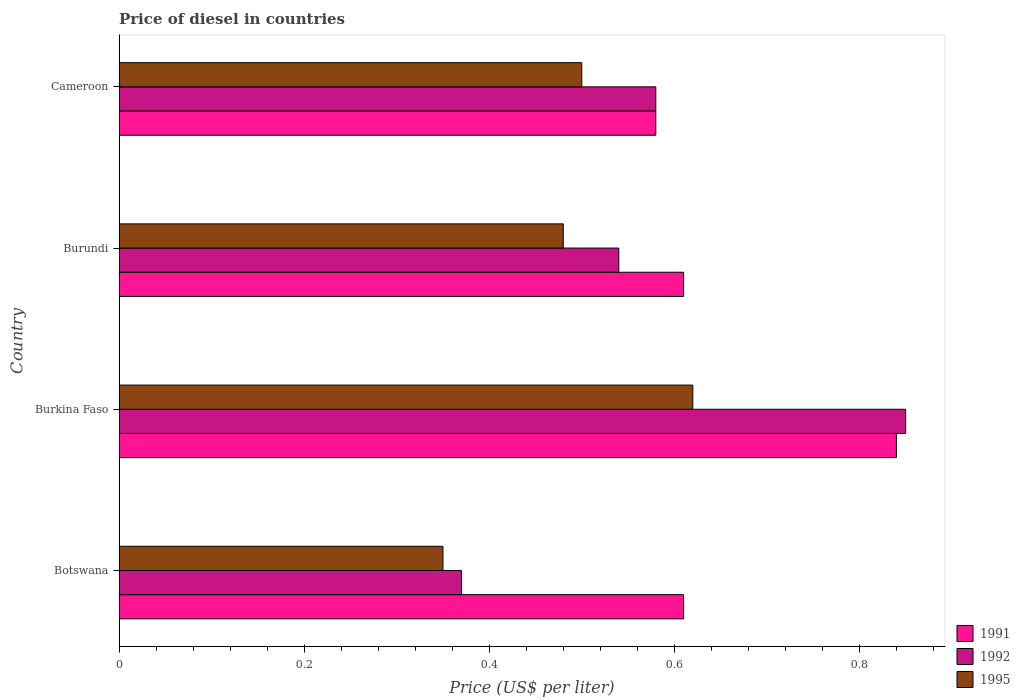How many different coloured bars are there?
Your answer should be very brief. 3. How many groups of bars are there?
Provide a short and direct response. 4. Are the number of bars per tick equal to the number of legend labels?
Your answer should be compact. Yes. How many bars are there on the 1st tick from the top?
Provide a succinct answer. 3. How many bars are there on the 1st tick from the bottom?
Provide a succinct answer. 3. What is the label of the 2nd group of bars from the top?
Your answer should be compact. Burundi. What is the price of diesel in 1991 in Botswana?
Your answer should be very brief. 0.61. Across all countries, what is the maximum price of diesel in 1991?
Provide a short and direct response. 0.84. In which country was the price of diesel in 1995 maximum?
Keep it short and to the point. Burkina Faso. In which country was the price of diesel in 1995 minimum?
Your response must be concise. Botswana. What is the total price of diesel in 1995 in the graph?
Your answer should be very brief. 1.95. What is the difference between the price of diesel in 1992 in Botswana and that in Burkina Faso?
Make the answer very short. -0.48. What is the difference between the price of diesel in 1992 in Cameroon and the price of diesel in 1991 in Botswana?
Your response must be concise. -0.03. What is the average price of diesel in 1992 per country?
Make the answer very short. 0.58. What is the difference between the price of diesel in 1992 and price of diesel in 1995 in Burkina Faso?
Your answer should be compact. 0.23. What is the ratio of the price of diesel in 1991 in Burkina Faso to that in Cameroon?
Your answer should be very brief. 1.45. Is the price of diesel in 1995 in Botswana less than that in Burundi?
Your response must be concise. Yes. What is the difference between the highest and the second highest price of diesel in 1991?
Your answer should be compact. 0.23. What is the difference between the highest and the lowest price of diesel in 1992?
Provide a succinct answer. 0.48. In how many countries, is the price of diesel in 1992 greater than the average price of diesel in 1992 taken over all countries?
Your answer should be very brief. 1. Is it the case that in every country, the sum of the price of diesel in 1992 and price of diesel in 1995 is greater than the price of diesel in 1991?
Provide a succinct answer. Yes. How many countries are there in the graph?
Your answer should be very brief. 4. What is the difference between two consecutive major ticks on the X-axis?
Ensure brevity in your answer.  0.2. Does the graph contain any zero values?
Ensure brevity in your answer.  No. How many legend labels are there?
Your answer should be compact. 3. What is the title of the graph?
Ensure brevity in your answer.  Price of diesel in countries. Does "2014" appear as one of the legend labels in the graph?
Give a very brief answer. No. What is the label or title of the X-axis?
Offer a very short reply. Price (US$ per liter). What is the Price (US$ per liter) in 1991 in Botswana?
Offer a very short reply. 0.61. What is the Price (US$ per liter) in 1992 in Botswana?
Offer a very short reply. 0.37. What is the Price (US$ per liter) in 1995 in Botswana?
Your answer should be very brief. 0.35. What is the Price (US$ per liter) in 1991 in Burkina Faso?
Your answer should be very brief. 0.84. What is the Price (US$ per liter) in 1992 in Burkina Faso?
Offer a terse response. 0.85. What is the Price (US$ per liter) in 1995 in Burkina Faso?
Offer a terse response. 0.62. What is the Price (US$ per liter) in 1991 in Burundi?
Your response must be concise. 0.61. What is the Price (US$ per liter) of 1992 in Burundi?
Keep it short and to the point. 0.54. What is the Price (US$ per liter) in 1995 in Burundi?
Make the answer very short. 0.48. What is the Price (US$ per liter) in 1991 in Cameroon?
Provide a succinct answer. 0.58. What is the Price (US$ per liter) of 1992 in Cameroon?
Offer a very short reply. 0.58. What is the Price (US$ per liter) in 1995 in Cameroon?
Make the answer very short. 0.5. Across all countries, what is the maximum Price (US$ per liter) in 1991?
Give a very brief answer. 0.84. Across all countries, what is the maximum Price (US$ per liter) in 1992?
Your response must be concise. 0.85. Across all countries, what is the maximum Price (US$ per liter) of 1995?
Offer a terse response. 0.62. Across all countries, what is the minimum Price (US$ per liter) in 1991?
Provide a short and direct response. 0.58. Across all countries, what is the minimum Price (US$ per liter) in 1992?
Ensure brevity in your answer.  0.37. Across all countries, what is the minimum Price (US$ per liter) of 1995?
Your response must be concise. 0.35. What is the total Price (US$ per liter) in 1991 in the graph?
Keep it short and to the point. 2.64. What is the total Price (US$ per liter) of 1992 in the graph?
Keep it short and to the point. 2.34. What is the total Price (US$ per liter) in 1995 in the graph?
Provide a short and direct response. 1.95. What is the difference between the Price (US$ per liter) in 1991 in Botswana and that in Burkina Faso?
Your answer should be compact. -0.23. What is the difference between the Price (US$ per liter) in 1992 in Botswana and that in Burkina Faso?
Ensure brevity in your answer.  -0.48. What is the difference between the Price (US$ per liter) of 1995 in Botswana and that in Burkina Faso?
Your answer should be very brief. -0.27. What is the difference between the Price (US$ per liter) in 1992 in Botswana and that in Burundi?
Offer a terse response. -0.17. What is the difference between the Price (US$ per liter) of 1995 in Botswana and that in Burundi?
Keep it short and to the point. -0.13. What is the difference between the Price (US$ per liter) in 1991 in Botswana and that in Cameroon?
Your response must be concise. 0.03. What is the difference between the Price (US$ per liter) in 1992 in Botswana and that in Cameroon?
Your answer should be compact. -0.21. What is the difference between the Price (US$ per liter) in 1991 in Burkina Faso and that in Burundi?
Your response must be concise. 0.23. What is the difference between the Price (US$ per liter) of 1992 in Burkina Faso and that in Burundi?
Your answer should be compact. 0.31. What is the difference between the Price (US$ per liter) of 1995 in Burkina Faso and that in Burundi?
Make the answer very short. 0.14. What is the difference between the Price (US$ per liter) in 1991 in Burkina Faso and that in Cameroon?
Your answer should be very brief. 0.26. What is the difference between the Price (US$ per liter) in 1992 in Burkina Faso and that in Cameroon?
Provide a succinct answer. 0.27. What is the difference between the Price (US$ per liter) of 1995 in Burkina Faso and that in Cameroon?
Offer a terse response. 0.12. What is the difference between the Price (US$ per liter) in 1991 in Burundi and that in Cameroon?
Offer a very short reply. 0.03. What is the difference between the Price (US$ per liter) in 1992 in Burundi and that in Cameroon?
Provide a succinct answer. -0.04. What is the difference between the Price (US$ per liter) in 1995 in Burundi and that in Cameroon?
Provide a succinct answer. -0.02. What is the difference between the Price (US$ per liter) in 1991 in Botswana and the Price (US$ per liter) in 1992 in Burkina Faso?
Make the answer very short. -0.24. What is the difference between the Price (US$ per liter) in 1991 in Botswana and the Price (US$ per liter) in 1995 in Burkina Faso?
Ensure brevity in your answer.  -0.01. What is the difference between the Price (US$ per liter) of 1991 in Botswana and the Price (US$ per liter) of 1992 in Burundi?
Keep it short and to the point. 0.07. What is the difference between the Price (US$ per liter) of 1991 in Botswana and the Price (US$ per liter) of 1995 in Burundi?
Offer a very short reply. 0.13. What is the difference between the Price (US$ per liter) of 1992 in Botswana and the Price (US$ per liter) of 1995 in Burundi?
Your answer should be compact. -0.11. What is the difference between the Price (US$ per liter) of 1991 in Botswana and the Price (US$ per liter) of 1995 in Cameroon?
Your answer should be compact. 0.11. What is the difference between the Price (US$ per liter) of 1992 in Botswana and the Price (US$ per liter) of 1995 in Cameroon?
Ensure brevity in your answer.  -0.13. What is the difference between the Price (US$ per liter) of 1991 in Burkina Faso and the Price (US$ per liter) of 1995 in Burundi?
Offer a very short reply. 0.36. What is the difference between the Price (US$ per liter) in 1992 in Burkina Faso and the Price (US$ per liter) in 1995 in Burundi?
Ensure brevity in your answer.  0.37. What is the difference between the Price (US$ per liter) in 1991 in Burkina Faso and the Price (US$ per liter) in 1992 in Cameroon?
Provide a short and direct response. 0.26. What is the difference between the Price (US$ per liter) in 1991 in Burkina Faso and the Price (US$ per liter) in 1995 in Cameroon?
Offer a very short reply. 0.34. What is the difference between the Price (US$ per liter) of 1992 in Burkina Faso and the Price (US$ per liter) of 1995 in Cameroon?
Your answer should be very brief. 0.35. What is the difference between the Price (US$ per liter) of 1991 in Burundi and the Price (US$ per liter) of 1995 in Cameroon?
Provide a short and direct response. 0.11. What is the average Price (US$ per liter) in 1991 per country?
Provide a short and direct response. 0.66. What is the average Price (US$ per liter) of 1992 per country?
Ensure brevity in your answer.  0.58. What is the average Price (US$ per liter) in 1995 per country?
Your answer should be compact. 0.49. What is the difference between the Price (US$ per liter) of 1991 and Price (US$ per liter) of 1992 in Botswana?
Offer a very short reply. 0.24. What is the difference between the Price (US$ per liter) in 1991 and Price (US$ per liter) in 1995 in Botswana?
Offer a terse response. 0.26. What is the difference between the Price (US$ per liter) in 1991 and Price (US$ per liter) in 1992 in Burkina Faso?
Your answer should be very brief. -0.01. What is the difference between the Price (US$ per liter) in 1991 and Price (US$ per liter) in 1995 in Burkina Faso?
Provide a succinct answer. 0.22. What is the difference between the Price (US$ per liter) of 1992 and Price (US$ per liter) of 1995 in Burkina Faso?
Provide a short and direct response. 0.23. What is the difference between the Price (US$ per liter) in 1991 and Price (US$ per liter) in 1992 in Burundi?
Make the answer very short. 0.07. What is the difference between the Price (US$ per liter) in 1991 and Price (US$ per liter) in 1995 in Burundi?
Offer a terse response. 0.13. What is the difference between the Price (US$ per liter) in 1992 and Price (US$ per liter) in 1995 in Burundi?
Keep it short and to the point. 0.06. What is the difference between the Price (US$ per liter) in 1991 and Price (US$ per liter) in 1992 in Cameroon?
Offer a terse response. 0. What is the ratio of the Price (US$ per liter) of 1991 in Botswana to that in Burkina Faso?
Offer a terse response. 0.73. What is the ratio of the Price (US$ per liter) in 1992 in Botswana to that in Burkina Faso?
Offer a very short reply. 0.44. What is the ratio of the Price (US$ per liter) of 1995 in Botswana to that in Burkina Faso?
Give a very brief answer. 0.56. What is the ratio of the Price (US$ per liter) in 1992 in Botswana to that in Burundi?
Your response must be concise. 0.69. What is the ratio of the Price (US$ per liter) in 1995 in Botswana to that in Burundi?
Offer a terse response. 0.73. What is the ratio of the Price (US$ per liter) of 1991 in Botswana to that in Cameroon?
Provide a succinct answer. 1.05. What is the ratio of the Price (US$ per liter) in 1992 in Botswana to that in Cameroon?
Keep it short and to the point. 0.64. What is the ratio of the Price (US$ per liter) of 1991 in Burkina Faso to that in Burundi?
Keep it short and to the point. 1.38. What is the ratio of the Price (US$ per liter) in 1992 in Burkina Faso to that in Burundi?
Provide a short and direct response. 1.57. What is the ratio of the Price (US$ per liter) of 1995 in Burkina Faso to that in Burundi?
Give a very brief answer. 1.29. What is the ratio of the Price (US$ per liter) of 1991 in Burkina Faso to that in Cameroon?
Your answer should be very brief. 1.45. What is the ratio of the Price (US$ per liter) of 1992 in Burkina Faso to that in Cameroon?
Your response must be concise. 1.47. What is the ratio of the Price (US$ per liter) of 1995 in Burkina Faso to that in Cameroon?
Keep it short and to the point. 1.24. What is the ratio of the Price (US$ per liter) of 1991 in Burundi to that in Cameroon?
Ensure brevity in your answer.  1.05. What is the ratio of the Price (US$ per liter) of 1995 in Burundi to that in Cameroon?
Provide a succinct answer. 0.96. What is the difference between the highest and the second highest Price (US$ per liter) in 1991?
Your response must be concise. 0.23. What is the difference between the highest and the second highest Price (US$ per liter) in 1992?
Make the answer very short. 0.27. What is the difference between the highest and the second highest Price (US$ per liter) of 1995?
Give a very brief answer. 0.12. What is the difference between the highest and the lowest Price (US$ per liter) of 1991?
Give a very brief answer. 0.26. What is the difference between the highest and the lowest Price (US$ per liter) in 1992?
Offer a very short reply. 0.48. What is the difference between the highest and the lowest Price (US$ per liter) of 1995?
Your answer should be very brief. 0.27. 